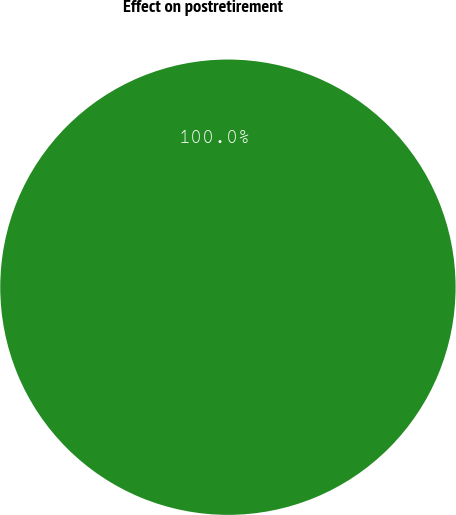<chart> <loc_0><loc_0><loc_500><loc_500><pie_chart><fcel>Effect on postretirement<nl><fcel>100.0%<nl></chart> 